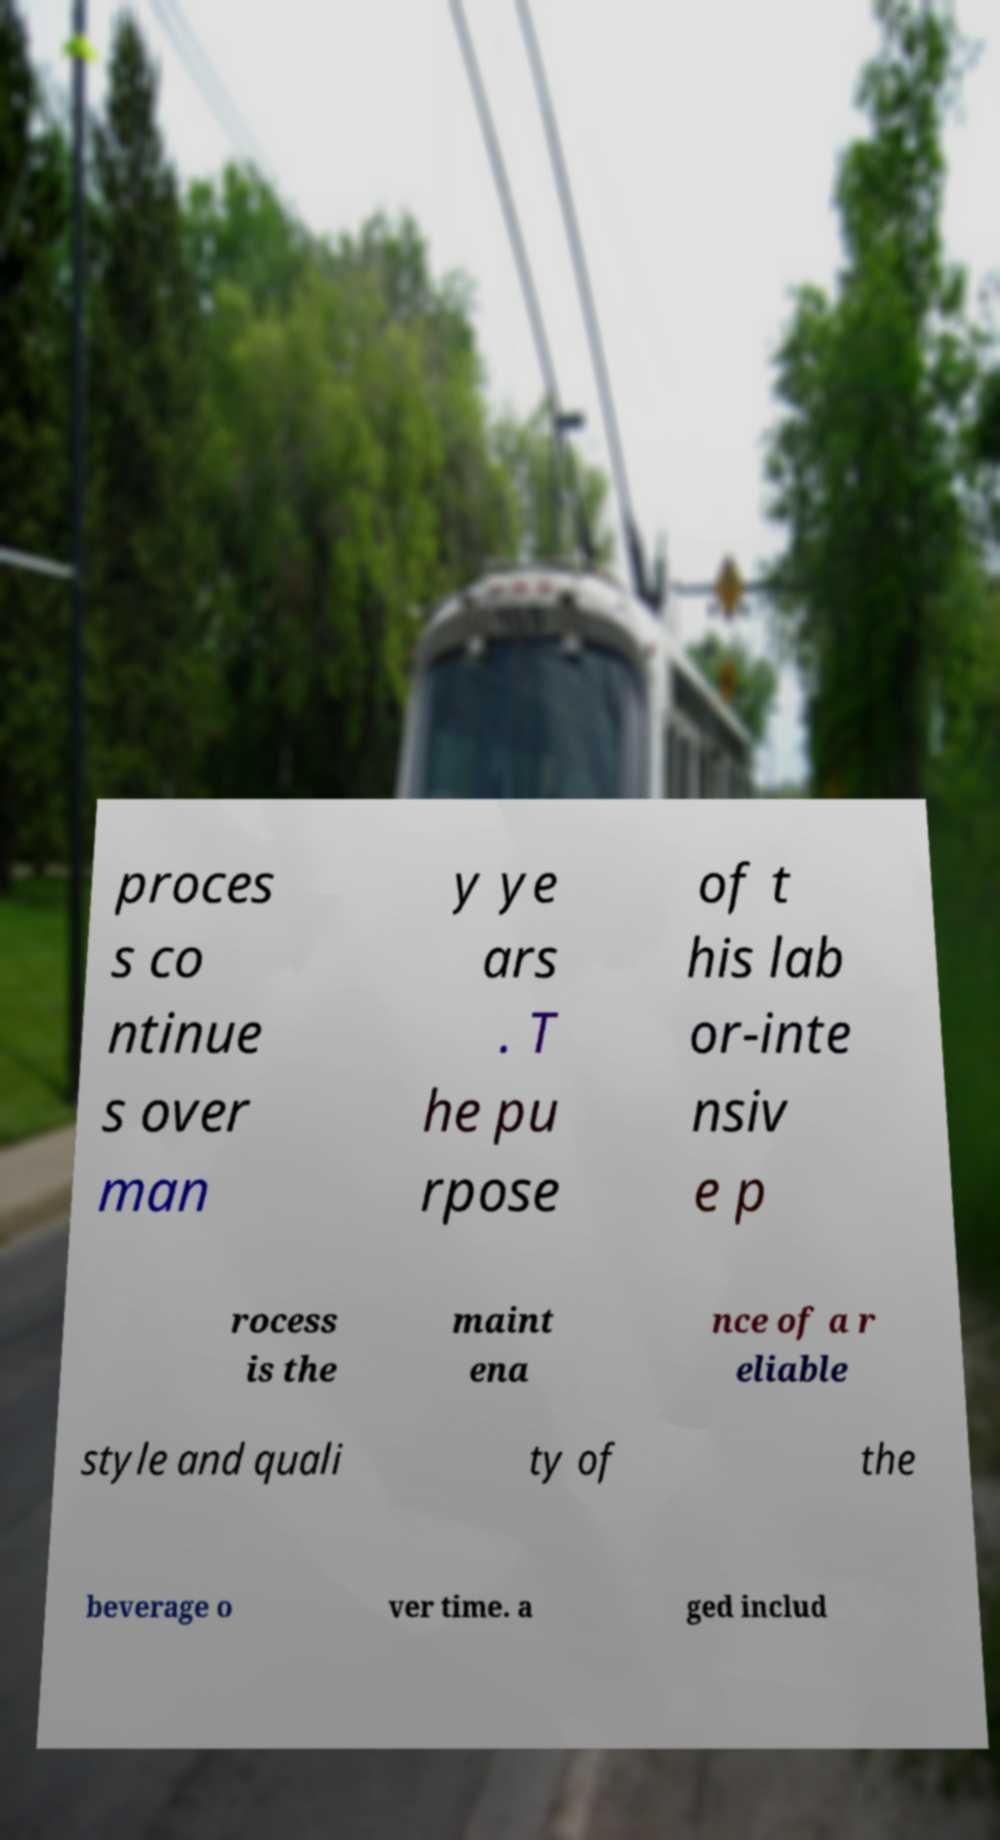Could you extract and type out the text from this image? proces s co ntinue s over man y ye ars . T he pu rpose of t his lab or-inte nsiv e p rocess is the maint ena nce of a r eliable style and quali ty of the beverage o ver time. a ged includ 